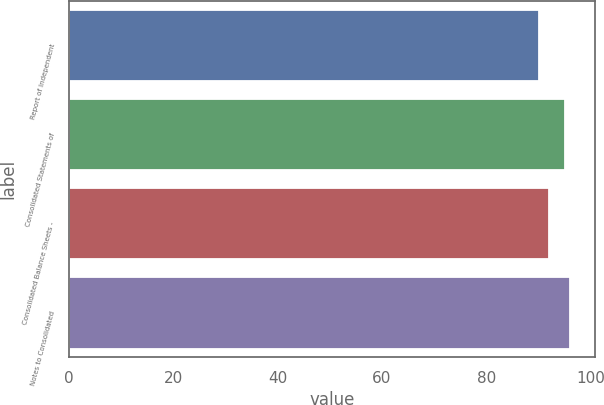Convert chart to OTSL. <chart><loc_0><loc_0><loc_500><loc_500><bar_chart><fcel>Report of Independent<fcel>Consolidated Statements of<fcel>Consolidated Balance Sheets -<fcel>Notes to Consolidated<nl><fcel>90<fcel>95<fcel>92<fcel>96<nl></chart> 